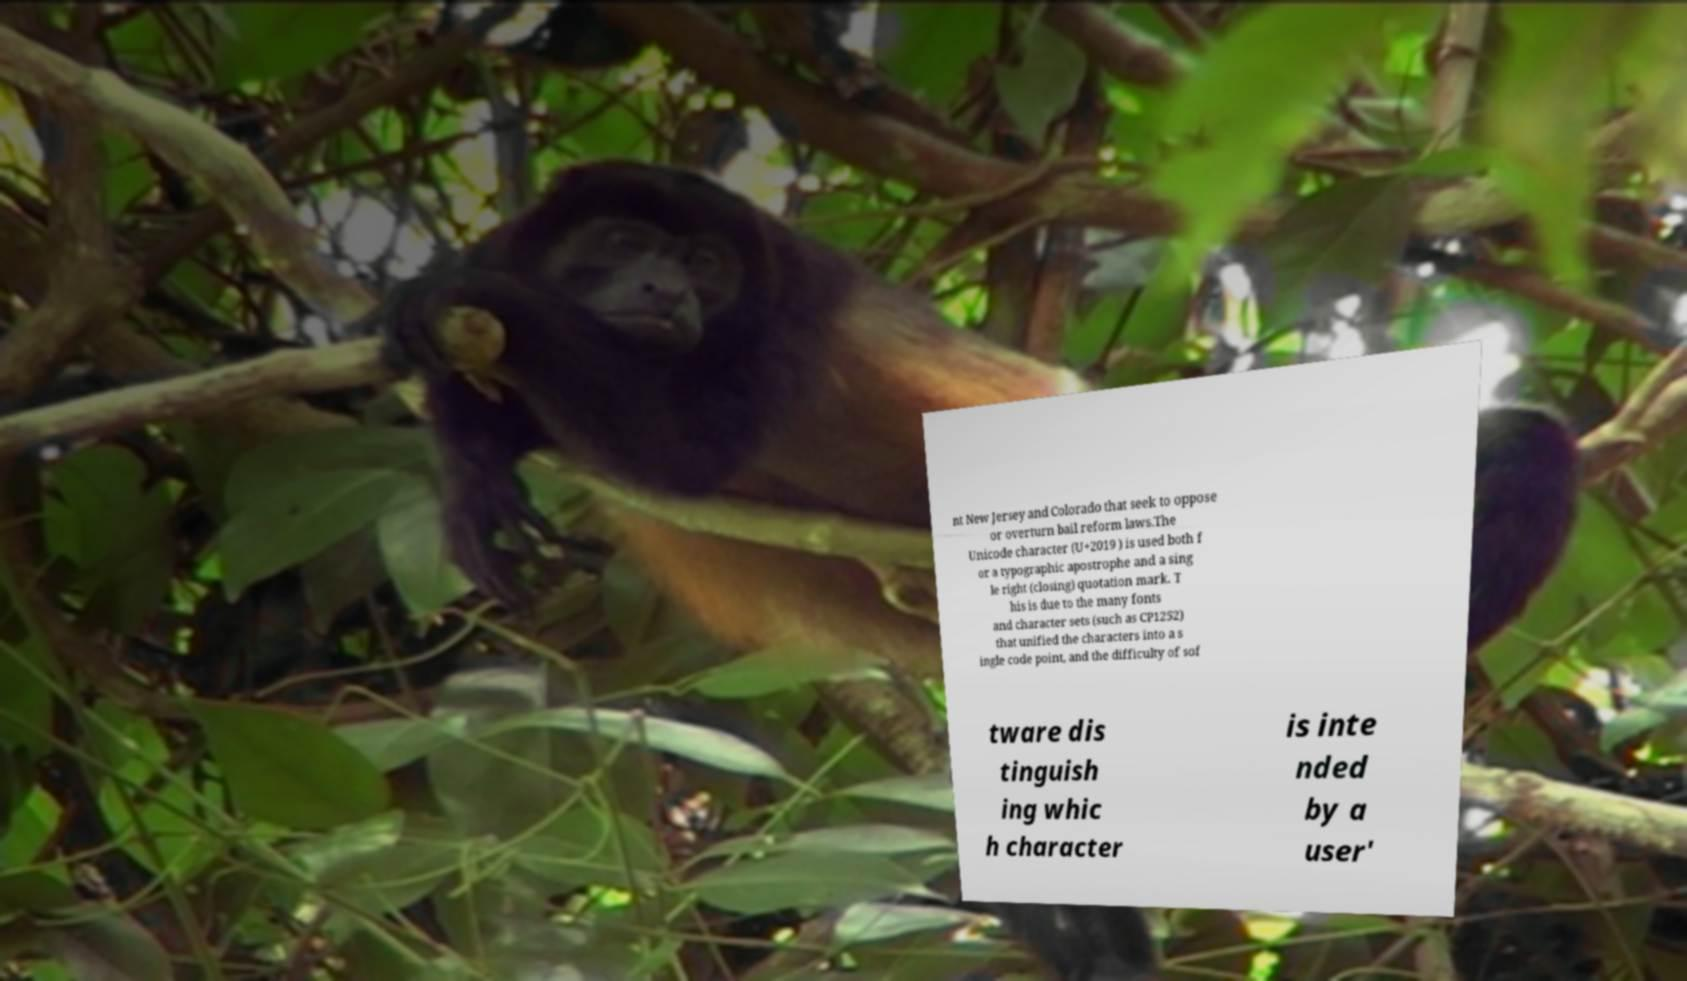Can you read and provide the text displayed in the image?This photo seems to have some interesting text. Can you extract and type it out for me? nt New Jersey and Colorado that seek to oppose or overturn bail reform laws.The Unicode character (U+2019 ) is used both f or a typographic apostrophe and a sing le right (closing) quotation mark. T his is due to the many fonts and character sets (such as CP1252) that unified the characters into a s ingle code point, and the difficulty of sof tware dis tinguish ing whic h character is inte nded by a user' 